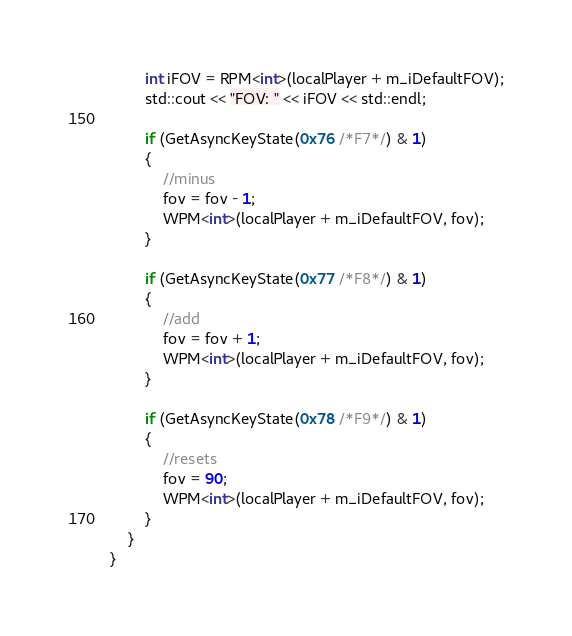Convert code to text. <code><loc_0><loc_0><loc_500><loc_500><_C++_>		int iFOV = RPM<int>(localPlayer + m_iDefaultFOV);
		std::cout << "FOV: " << iFOV << std::endl;

		if (GetAsyncKeyState(0x76 /*F7*/) & 1)
		{
			//minus
			fov = fov - 1;
			WPM<int>(localPlayer + m_iDefaultFOV, fov);
		}

		if (GetAsyncKeyState(0x77 /*F8*/) & 1)
		{
			//add
			fov = fov + 1;
			WPM<int>(localPlayer + m_iDefaultFOV, fov);
		}

		if (GetAsyncKeyState(0x78 /*F9*/) & 1)
		{
			//resets
			fov = 90;
			WPM<int>(localPlayer + m_iDefaultFOV, fov);
		}
	}
}</code> 